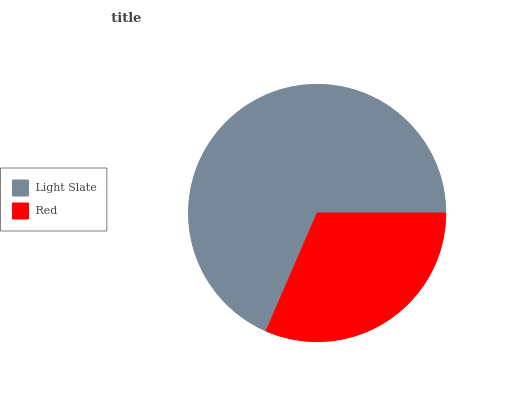Is Red the minimum?
Answer yes or no. Yes. Is Light Slate the maximum?
Answer yes or no. Yes. Is Red the maximum?
Answer yes or no. No. Is Light Slate greater than Red?
Answer yes or no. Yes. Is Red less than Light Slate?
Answer yes or no. Yes. Is Red greater than Light Slate?
Answer yes or no. No. Is Light Slate less than Red?
Answer yes or no. No. Is Light Slate the high median?
Answer yes or no. Yes. Is Red the low median?
Answer yes or no. Yes. Is Red the high median?
Answer yes or no. No. Is Light Slate the low median?
Answer yes or no. No. 